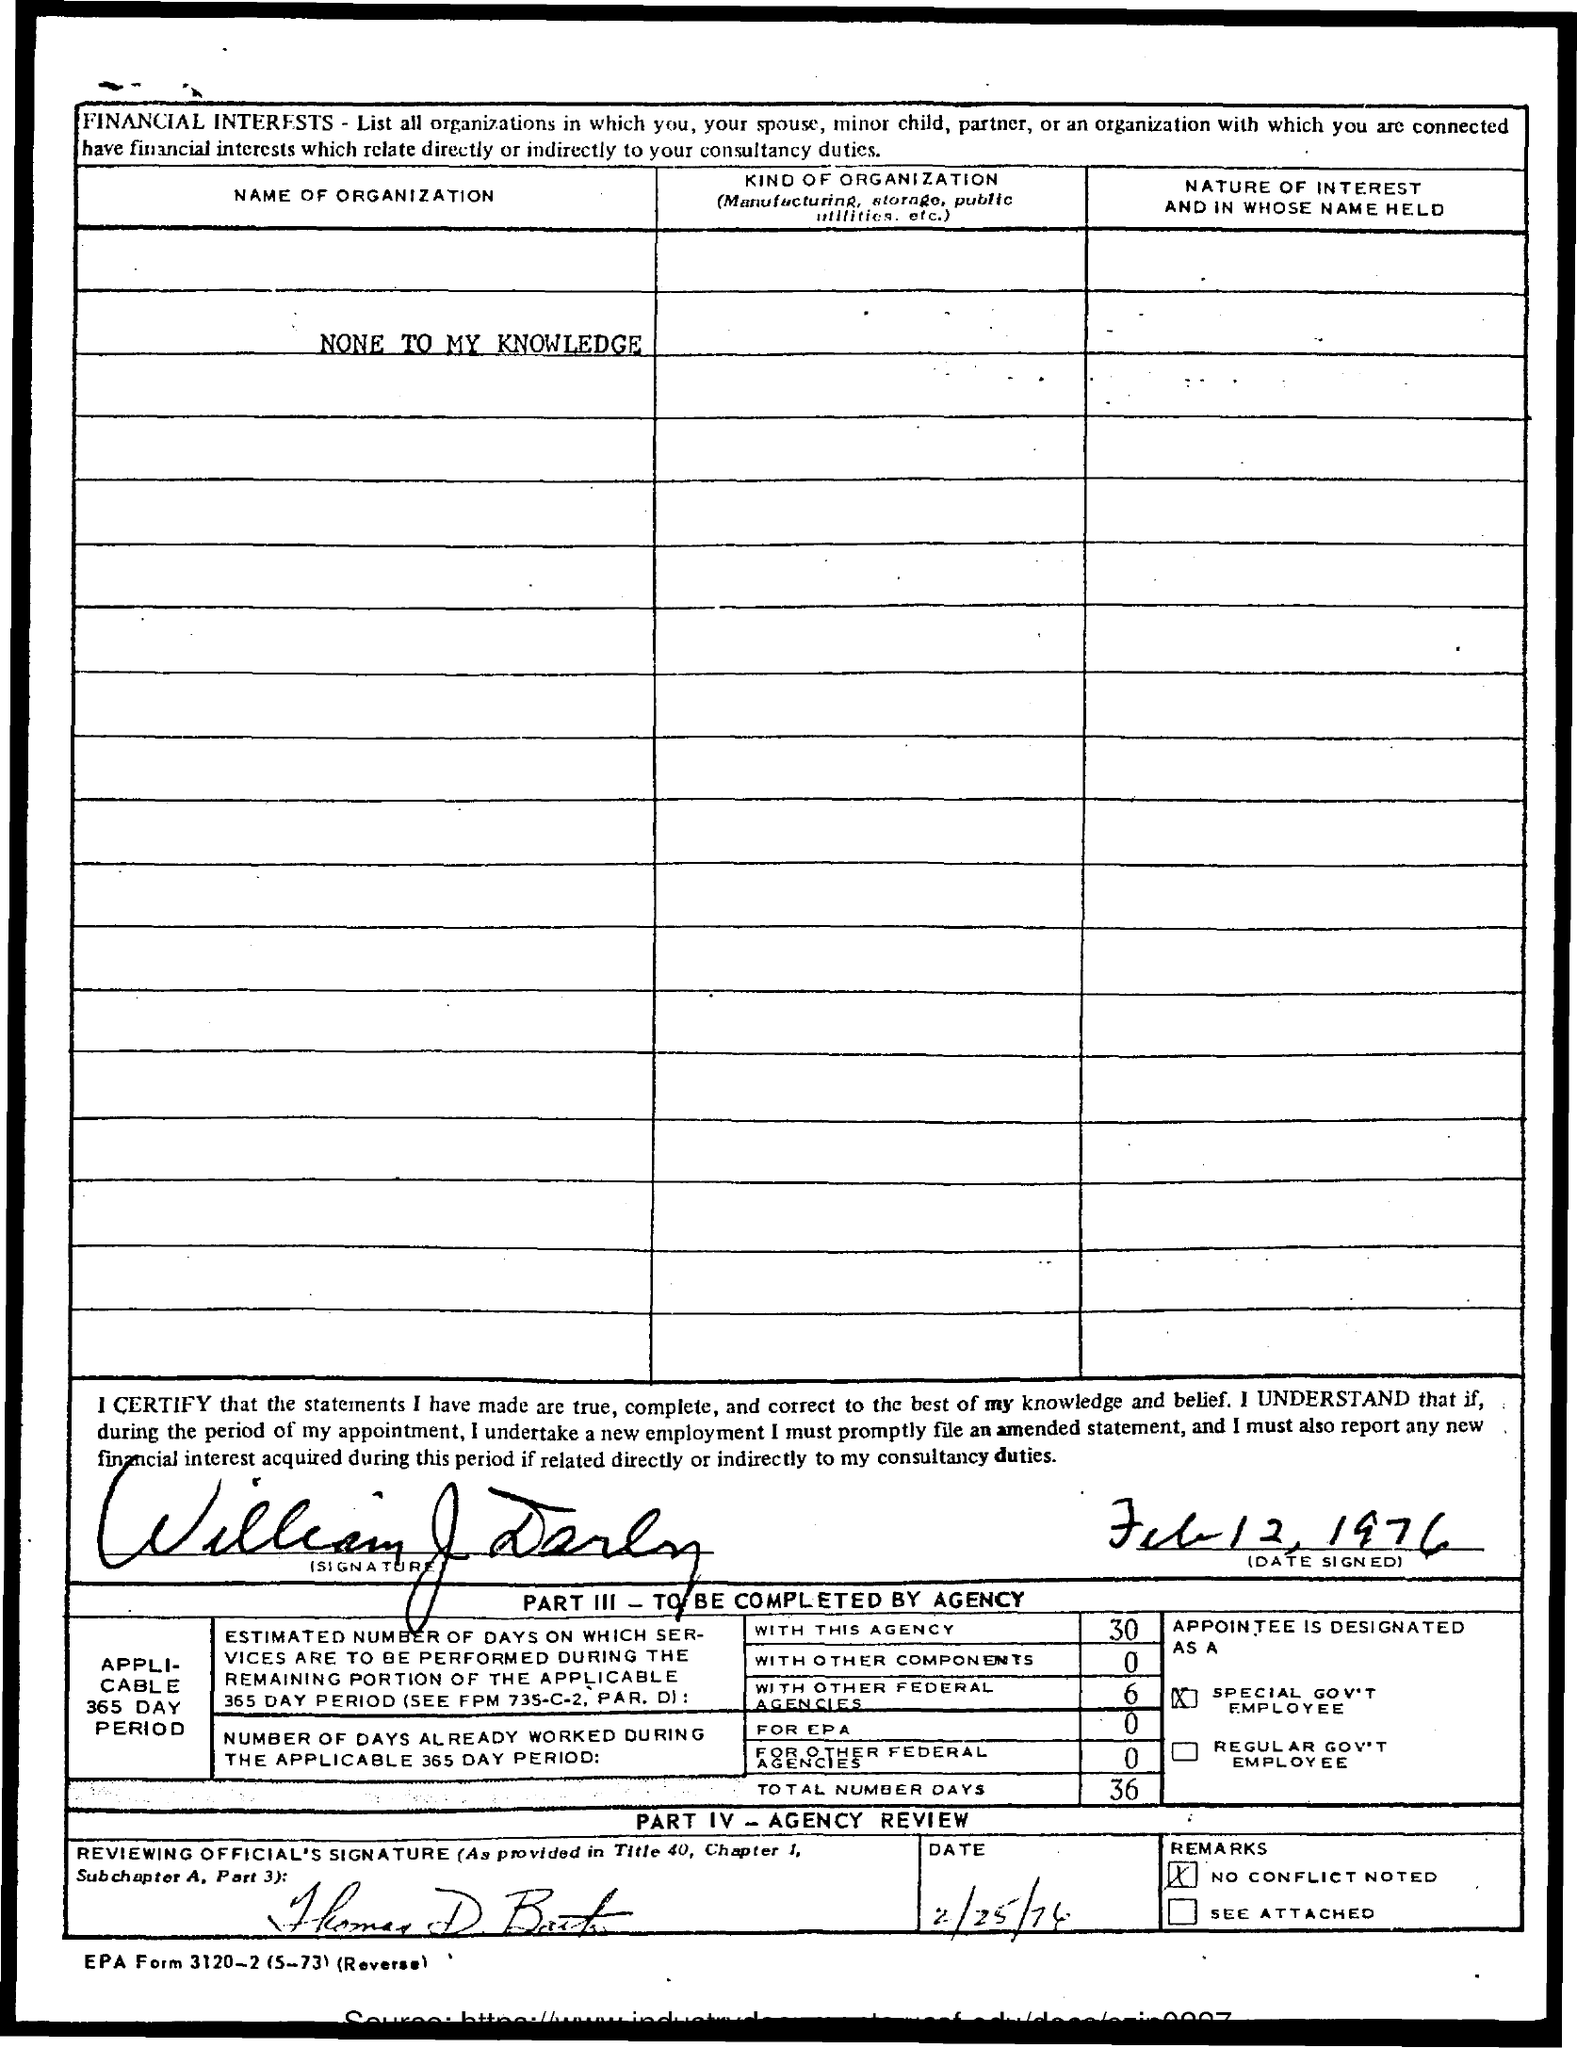Specify some key components in this picture. The date of the signing is February 12, 1976. 